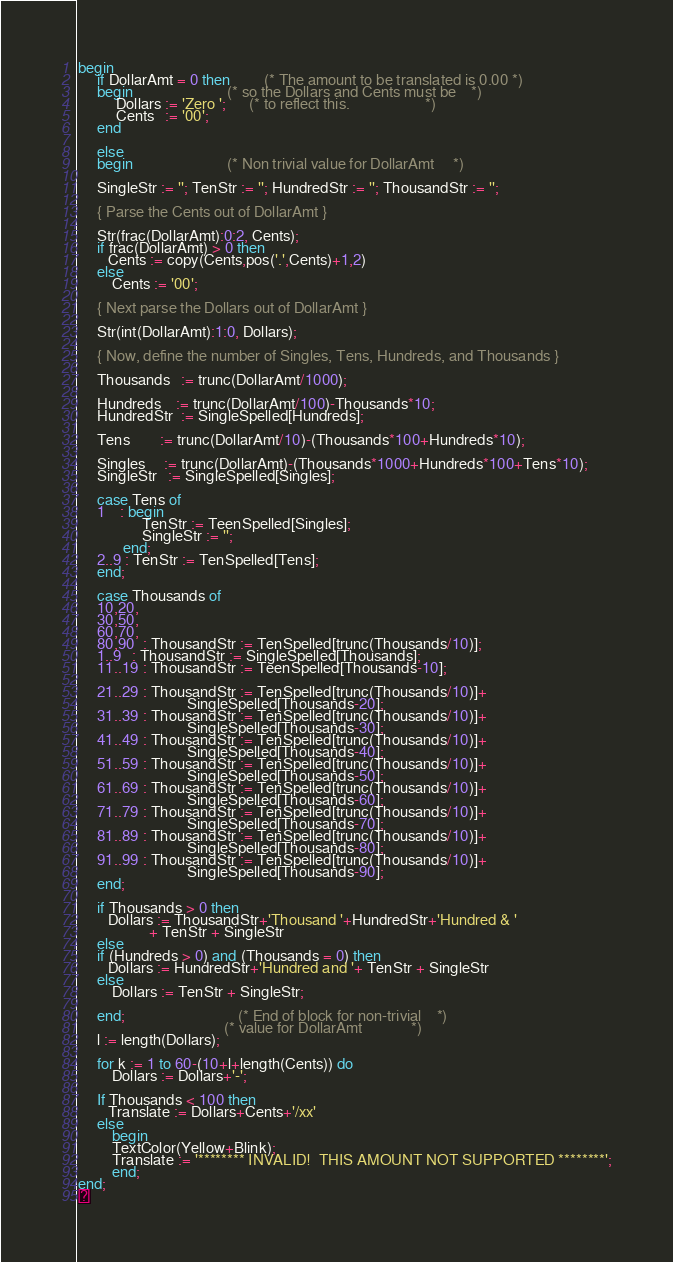<code> <loc_0><loc_0><loc_500><loc_500><_Pascal_>
begin
     if DollarAmt = 0 then         (* The amount to be translated is 0.00 *)
     begin                         (* so the Dollars and Cents must be    *)
          Dollars := 'Zero ';      (* to reflect this.                    *)
          Cents   := '00';
     end

     else
     begin                         (* Non trivial value for DollarAmt     *)

     SingleStr := ''; TenStr := ''; HundredStr := ''; ThousandStr := '';

     { Parse the Cents out of DollarAmt }

     Str(frac(DollarAmt):0:2, Cents);
     if frac(DollarAmt) > 0 then
        Cents := copy(Cents,pos('.',Cents)+1,2)
     else
         Cents := '00';

     { Next parse the Dollars out of DollarAmt }

     Str(int(DollarAmt):1:0, Dollars);

     { Now, define the number of Singles, Tens, Hundreds, and Thousands }

     Thousands   := trunc(DollarAmt/1000);

     Hundreds    := trunc(DollarAmt/100)-Thousands*10;
     HundredStr  := SingleSpelled[Hundreds];

     Tens        := trunc(DollarAmt/10)-(Thousands*100+Hundreds*10);

     Singles     := trunc(DollarAmt)-(Thousands*1000+Hundreds*100+Tens*10);
     SingleStr   := SingleSpelled[Singles];

     case Tens of
     1    : begin
                 TenStr := TeenSpelled[Singles];
                 SingleStr := '';
            end;
     2..9 : TenStr := TenSpelled[Tens];
     end;

     case Thousands of
     10,20,
     30,50,
     60,70,
     80,90  : ThousandStr := TenSpelled[trunc(Thousands/10)];
     1..9   : ThousandStr := SingleSpelled[Thousands];
     11..19 : ThousandStr := TeenSpelled[Thousands-10];

     21..29 : ThousandStr := TenSpelled[trunc(Thousands/10)]+
                             SingleSpelled[Thousands-20];
     31..39 : ThousandStr := TenSpelled[trunc(Thousands/10)]+
                             SingleSpelled[Thousands-30];
     41..49 : ThousandStr := TenSpelled[trunc(Thousands/10)]+
                             SingleSpelled[Thousands-40];
     51..59 : ThousandStr := TenSpelled[trunc(Thousands/10)]+
                             SingleSpelled[Thousands-50];
     61..69 : ThousandStr := TenSpelled[trunc(Thousands/10)]+
                             SingleSpelled[Thousands-60];
     71..79 : ThousandStr := TenSpelled[trunc(Thousands/10)]+
                             SingleSpelled[Thousands-70];
     81..89 : ThousandStr := TenSpelled[trunc(Thousands/10)]+
                             SingleSpelled[Thousands-80];
     91..99 : ThousandStr := TenSpelled[trunc(Thousands/10)]+
                             SingleSpelled[Thousands-90];
     end;

     if Thousands > 0 then
        Dollars := ThousandStr+'Thousand '+HundredStr+'Hundred & '
                   + TenStr + SingleStr
     else
     if (Hundreds > 0) and (Thousands = 0) then
        Dollars := HundredStr+'Hundred and '+ TenStr + SingleStr
     else
         Dollars := TenStr + SingleStr;

     end;                              (* End of block for non-trivial    *)
                                       (* value for DollarAmt             *)
     l := length(Dollars);

     for k := 1 to 60-(10+l+length(Cents)) do
         Dollars := Dollars+'-';

     If Thousands < 100 then
        Translate := Dollars+Cents+'/xx'
     else
         begin
         TextColor(Yellow+Blink);
         Translate := '******** INVALID!  THIS AMOUNT NOT SUPPORTED ********';
         end;
end;
</code> 